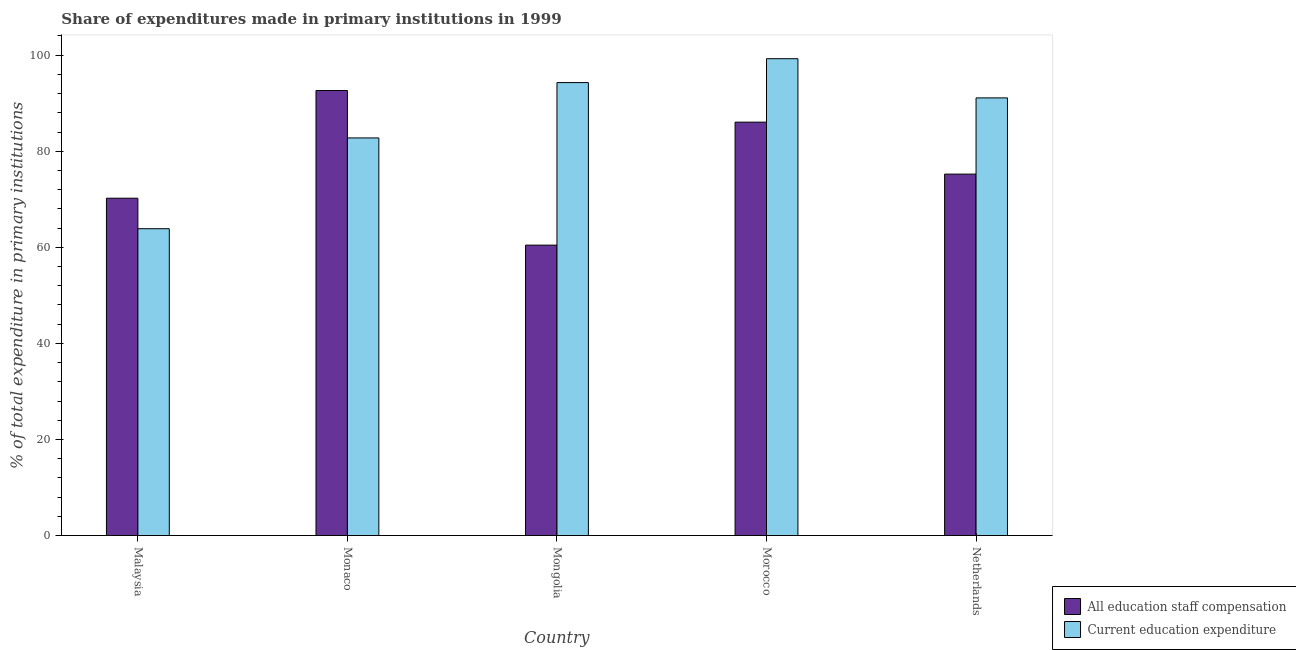How many different coloured bars are there?
Keep it short and to the point. 2. Are the number of bars on each tick of the X-axis equal?
Ensure brevity in your answer.  Yes. What is the label of the 4th group of bars from the left?
Give a very brief answer. Morocco. What is the expenditure in staff compensation in Mongolia?
Offer a very short reply. 60.46. Across all countries, what is the maximum expenditure in education?
Your answer should be compact. 99.27. Across all countries, what is the minimum expenditure in education?
Make the answer very short. 63.88. In which country was the expenditure in staff compensation maximum?
Offer a very short reply. Monaco. In which country was the expenditure in staff compensation minimum?
Ensure brevity in your answer.  Mongolia. What is the total expenditure in education in the graph?
Your response must be concise. 431.34. What is the difference between the expenditure in education in Morocco and that in Netherlands?
Ensure brevity in your answer.  8.16. What is the difference between the expenditure in education in Netherlands and the expenditure in staff compensation in Mongolia?
Provide a succinct answer. 30.65. What is the average expenditure in staff compensation per country?
Offer a terse response. 76.93. What is the difference between the expenditure in education and expenditure in staff compensation in Netherlands?
Keep it short and to the point. 15.87. In how many countries, is the expenditure in education greater than 60 %?
Provide a short and direct response. 5. What is the ratio of the expenditure in staff compensation in Malaysia to that in Monaco?
Your answer should be very brief. 0.76. Is the expenditure in education in Mongolia less than that in Morocco?
Your response must be concise. Yes. Is the difference between the expenditure in staff compensation in Malaysia and Morocco greater than the difference between the expenditure in education in Malaysia and Morocco?
Your response must be concise. Yes. What is the difference between the highest and the second highest expenditure in education?
Your answer should be very brief. 4.97. What is the difference between the highest and the lowest expenditure in staff compensation?
Offer a terse response. 32.19. Is the sum of the expenditure in education in Malaysia and Mongolia greater than the maximum expenditure in staff compensation across all countries?
Your answer should be very brief. Yes. What does the 2nd bar from the left in Mongolia represents?
Keep it short and to the point. Current education expenditure. What does the 2nd bar from the right in Malaysia represents?
Make the answer very short. All education staff compensation. Are all the bars in the graph horizontal?
Ensure brevity in your answer.  No. What is the difference between two consecutive major ticks on the Y-axis?
Your answer should be compact. 20. Does the graph contain any zero values?
Offer a very short reply. No. Does the graph contain grids?
Make the answer very short. No. How many legend labels are there?
Offer a very short reply. 2. What is the title of the graph?
Offer a very short reply. Share of expenditures made in primary institutions in 1999. What is the label or title of the X-axis?
Provide a succinct answer. Country. What is the label or title of the Y-axis?
Provide a short and direct response. % of total expenditure in primary institutions. What is the % of total expenditure in primary institutions in All education staff compensation in Malaysia?
Offer a very short reply. 70.23. What is the % of total expenditure in primary institutions in Current education expenditure in Malaysia?
Ensure brevity in your answer.  63.88. What is the % of total expenditure in primary institutions of All education staff compensation in Monaco?
Give a very brief answer. 92.65. What is the % of total expenditure in primary institutions of Current education expenditure in Monaco?
Keep it short and to the point. 82.78. What is the % of total expenditure in primary institutions of All education staff compensation in Mongolia?
Your answer should be very brief. 60.46. What is the % of total expenditure in primary institutions of Current education expenditure in Mongolia?
Offer a terse response. 94.3. What is the % of total expenditure in primary institutions in All education staff compensation in Morocco?
Make the answer very short. 86.07. What is the % of total expenditure in primary institutions of Current education expenditure in Morocco?
Your answer should be compact. 99.27. What is the % of total expenditure in primary institutions in All education staff compensation in Netherlands?
Give a very brief answer. 75.25. What is the % of total expenditure in primary institutions in Current education expenditure in Netherlands?
Make the answer very short. 91.11. Across all countries, what is the maximum % of total expenditure in primary institutions of All education staff compensation?
Make the answer very short. 92.65. Across all countries, what is the maximum % of total expenditure in primary institutions of Current education expenditure?
Ensure brevity in your answer.  99.27. Across all countries, what is the minimum % of total expenditure in primary institutions of All education staff compensation?
Give a very brief answer. 60.46. Across all countries, what is the minimum % of total expenditure in primary institutions of Current education expenditure?
Your answer should be very brief. 63.88. What is the total % of total expenditure in primary institutions of All education staff compensation in the graph?
Provide a short and direct response. 384.66. What is the total % of total expenditure in primary institutions in Current education expenditure in the graph?
Your answer should be very brief. 431.34. What is the difference between the % of total expenditure in primary institutions of All education staff compensation in Malaysia and that in Monaco?
Keep it short and to the point. -22.43. What is the difference between the % of total expenditure in primary institutions in Current education expenditure in Malaysia and that in Monaco?
Ensure brevity in your answer.  -18.9. What is the difference between the % of total expenditure in primary institutions in All education staff compensation in Malaysia and that in Mongolia?
Give a very brief answer. 9.77. What is the difference between the % of total expenditure in primary institutions of Current education expenditure in Malaysia and that in Mongolia?
Ensure brevity in your answer.  -30.42. What is the difference between the % of total expenditure in primary institutions in All education staff compensation in Malaysia and that in Morocco?
Offer a very short reply. -15.84. What is the difference between the % of total expenditure in primary institutions in Current education expenditure in Malaysia and that in Morocco?
Offer a very short reply. -35.39. What is the difference between the % of total expenditure in primary institutions of All education staff compensation in Malaysia and that in Netherlands?
Keep it short and to the point. -5.02. What is the difference between the % of total expenditure in primary institutions in Current education expenditure in Malaysia and that in Netherlands?
Your answer should be very brief. -27.24. What is the difference between the % of total expenditure in primary institutions in All education staff compensation in Monaco and that in Mongolia?
Your response must be concise. 32.19. What is the difference between the % of total expenditure in primary institutions in Current education expenditure in Monaco and that in Mongolia?
Your answer should be very brief. -11.52. What is the difference between the % of total expenditure in primary institutions of All education staff compensation in Monaco and that in Morocco?
Give a very brief answer. 6.59. What is the difference between the % of total expenditure in primary institutions of Current education expenditure in Monaco and that in Morocco?
Make the answer very short. -16.49. What is the difference between the % of total expenditure in primary institutions of All education staff compensation in Monaco and that in Netherlands?
Your answer should be very brief. 17.41. What is the difference between the % of total expenditure in primary institutions in Current education expenditure in Monaco and that in Netherlands?
Provide a short and direct response. -8.34. What is the difference between the % of total expenditure in primary institutions in All education staff compensation in Mongolia and that in Morocco?
Offer a terse response. -25.6. What is the difference between the % of total expenditure in primary institutions of Current education expenditure in Mongolia and that in Morocco?
Make the answer very short. -4.97. What is the difference between the % of total expenditure in primary institutions in All education staff compensation in Mongolia and that in Netherlands?
Offer a terse response. -14.79. What is the difference between the % of total expenditure in primary institutions of Current education expenditure in Mongolia and that in Netherlands?
Offer a terse response. 3.19. What is the difference between the % of total expenditure in primary institutions in All education staff compensation in Morocco and that in Netherlands?
Provide a succinct answer. 10.82. What is the difference between the % of total expenditure in primary institutions of Current education expenditure in Morocco and that in Netherlands?
Keep it short and to the point. 8.16. What is the difference between the % of total expenditure in primary institutions in All education staff compensation in Malaysia and the % of total expenditure in primary institutions in Current education expenditure in Monaco?
Keep it short and to the point. -12.55. What is the difference between the % of total expenditure in primary institutions of All education staff compensation in Malaysia and the % of total expenditure in primary institutions of Current education expenditure in Mongolia?
Your answer should be compact. -24.07. What is the difference between the % of total expenditure in primary institutions of All education staff compensation in Malaysia and the % of total expenditure in primary institutions of Current education expenditure in Morocco?
Make the answer very short. -29.04. What is the difference between the % of total expenditure in primary institutions of All education staff compensation in Malaysia and the % of total expenditure in primary institutions of Current education expenditure in Netherlands?
Provide a succinct answer. -20.89. What is the difference between the % of total expenditure in primary institutions of All education staff compensation in Monaco and the % of total expenditure in primary institutions of Current education expenditure in Mongolia?
Provide a succinct answer. -1.65. What is the difference between the % of total expenditure in primary institutions of All education staff compensation in Monaco and the % of total expenditure in primary institutions of Current education expenditure in Morocco?
Your answer should be compact. -6.62. What is the difference between the % of total expenditure in primary institutions of All education staff compensation in Monaco and the % of total expenditure in primary institutions of Current education expenditure in Netherlands?
Your answer should be compact. 1.54. What is the difference between the % of total expenditure in primary institutions of All education staff compensation in Mongolia and the % of total expenditure in primary institutions of Current education expenditure in Morocco?
Ensure brevity in your answer.  -38.81. What is the difference between the % of total expenditure in primary institutions of All education staff compensation in Mongolia and the % of total expenditure in primary institutions of Current education expenditure in Netherlands?
Your answer should be compact. -30.65. What is the difference between the % of total expenditure in primary institutions of All education staff compensation in Morocco and the % of total expenditure in primary institutions of Current education expenditure in Netherlands?
Provide a succinct answer. -5.05. What is the average % of total expenditure in primary institutions in All education staff compensation per country?
Offer a terse response. 76.93. What is the average % of total expenditure in primary institutions of Current education expenditure per country?
Your answer should be compact. 86.27. What is the difference between the % of total expenditure in primary institutions of All education staff compensation and % of total expenditure in primary institutions of Current education expenditure in Malaysia?
Provide a short and direct response. 6.35. What is the difference between the % of total expenditure in primary institutions of All education staff compensation and % of total expenditure in primary institutions of Current education expenditure in Monaco?
Provide a short and direct response. 9.88. What is the difference between the % of total expenditure in primary institutions of All education staff compensation and % of total expenditure in primary institutions of Current education expenditure in Mongolia?
Offer a terse response. -33.84. What is the difference between the % of total expenditure in primary institutions in All education staff compensation and % of total expenditure in primary institutions in Current education expenditure in Morocco?
Offer a terse response. -13.2. What is the difference between the % of total expenditure in primary institutions of All education staff compensation and % of total expenditure in primary institutions of Current education expenditure in Netherlands?
Offer a terse response. -15.87. What is the ratio of the % of total expenditure in primary institutions of All education staff compensation in Malaysia to that in Monaco?
Provide a short and direct response. 0.76. What is the ratio of the % of total expenditure in primary institutions in Current education expenditure in Malaysia to that in Monaco?
Your answer should be compact. 0.77. What is the ratio of the % of total expenditure in primary institutions of All education staff compensation in Malaysia to that in Mongolia?
Offer a very short reply. 1.16. What is the ratio of the % of total expenditure in primary institutions in Current education expenditure in Malaysia to that in Mongolia?
Ensure brevity in your answer.  0.68. What is the ratio of the % of total expenditure in primary institutions of All education staff compensation in Malaysia to that in Morocco?
Give a very brief answer. 0.82. What is the ratio of the % of total expenditure in primary institutions of Current education expenditure in Malaysia to that in Morocco?
Offer a terse response. 0.64. What is the ratio of the % of total expenditure in primary institutions of All education staff compensation in Malaysia to that in Netherlands?
Your response must be concise. 0.93. What is the ratio of the % of total expenditure in primary institutions in Current education expenditure in Malaysia to that in Netherlands?
Your answer should be very brief. 0.7. What is the ratio of the % of total expenditure in primary institutions in All education staff compensation in Monaco to that in Mongolia?
Offer a terse response. 1.53. What is the ratio of the % of total expenditure in primary institutions in Current education expenditure in Monaco to that in Mongolia?
Keep it short and to the point. 0.88. What is the ratio of the % of total expenditure in primary institutions of All education staff compensation in Monaco to that in Morocco?
Your answer should be very brief. 1.08. What is the ratio of the % of total expenditure in primary institutions in Current education expenditure in Monaco to that in Morocco?
Make the answer very short. 0.83. What is the ratio of the % of total expenditure in primary institutions of All education staff compensation in Monaco to that in Netherlands?
Give a very brief answer. 1.23. What is the ratio of the % of total expenditure in primary institutions in Current education expenditure in Monaco to that in Netherlands?
Offer a terse response. 0.91. What is the ratio of the % of total expenditure in primary institutions of All education staff compensation in Mongolia to that in Morocco?
Provide a short and direct response. 0.7. What is the ratio of the % of total expenditure in primary institutions of All education staff compensation in Mongolia to that in Netherlands?
Your answer should be very brief. 0.8. What is the ratio of the % of total expenditure in primary institutions in Current education expenditure in Mongolia to that in Netherlands?
Make the answer very short. 1.03. What is the ratio of the % of total expenditure in primary institutions of All education staff compensation in Morocco to that in Netherlands?
Provide a succinct answer. 1.14. What is the ratio of the % of total expenditure in primary institutions of Current education expenditure in Morocco to that in Netherlands?
Provide a short and direct response. 1.09. What is the difference between the highest and the second highest % of total expenditure in primary institutions of All education staff compensation?
Your response must be concise. 6.59. What is the difference between the highest and the second highest % of total expenditure in primary institutions of Current education expenditure?
Provide a succinct answer. 4.97. What is the difference between the highest and the lowest % of total expenditure in primary institutions in All education staff compensation?
Your response must be concise. 32.19. What is the difference between the highest and the lowest % of total expenditure in primary institutions of Current education expenditure?
Your answer should be very brief. 35.39. 